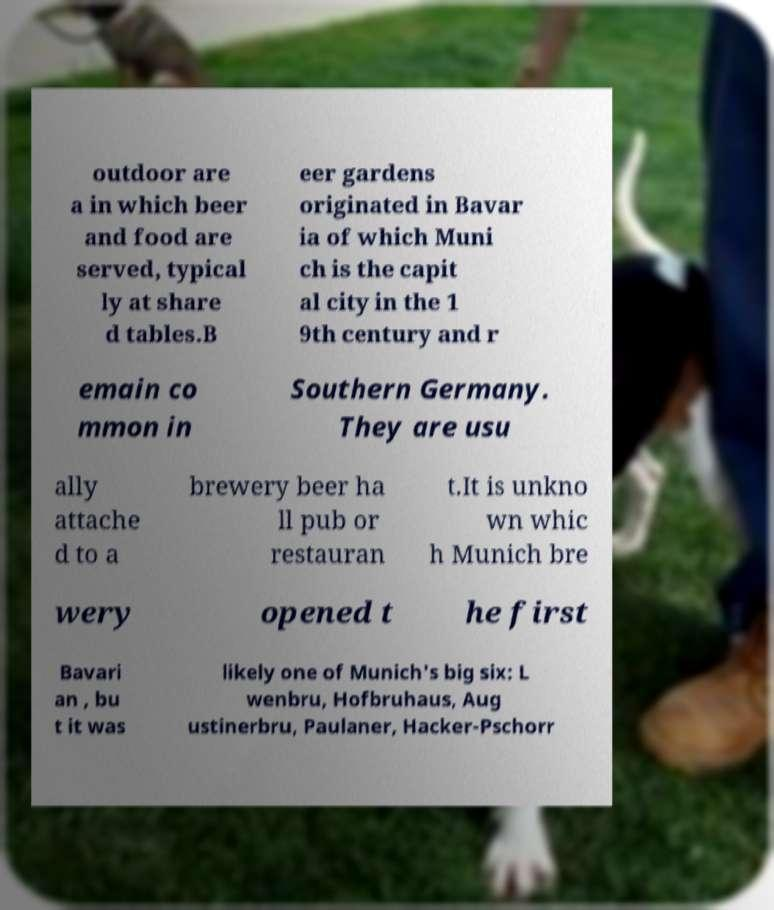What messages or text are displayed in this image? I need them in a readable, typed format. outdoor are a in which beer and food are served, typical ly at share d tables.B eer gardens originated in Bavar ia of which Muni ch is the capit al city in the 1 9th century and r emain co mmon in Southern Germany. They are usu ally attache d to a brewery beer ha ll pub or restauran t.It is unkno wn whic h Munich bre wery opened t he first Bavari an , bu t it was likely one of Munich's big six: L wenbru, Hofbruhaus, Aug ustinerbru, Paulaner, Hacker-Pschorr 